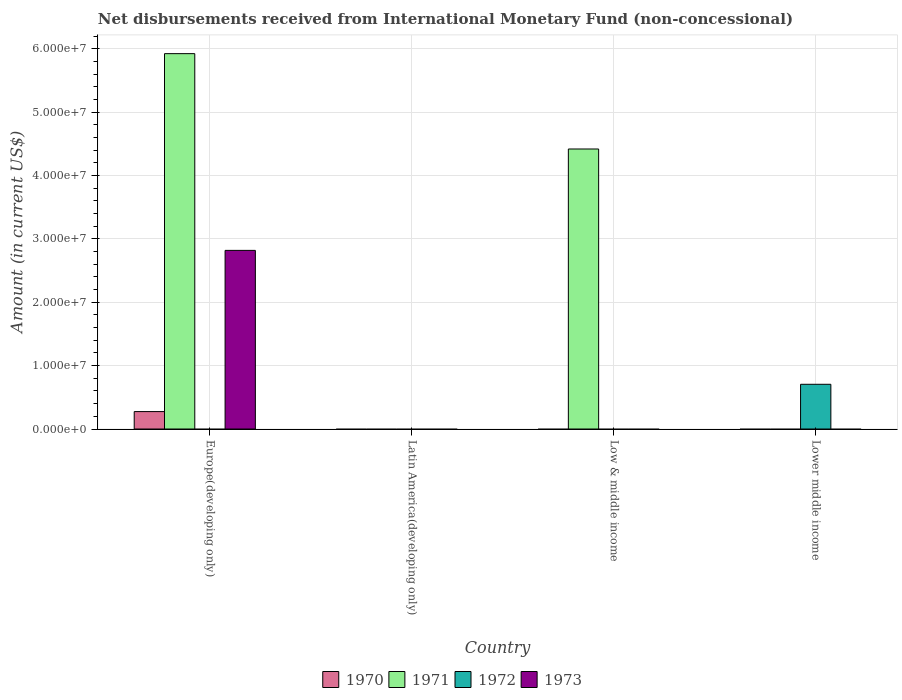How many different coloured bars are there?
Provide a succinct answer. 4. Are the number of bars on each tick of the X-axis equal?
Your answer should be compact. No. What is the label of the 1st group of bars from the left?
Give a very brief answer. Europe(developing only). In how many cases, is the number of bars for a given country not equal to the number of legend labels?
Provide a succinct answer. 4. Across all countries, what is the maximum amount of disbursements received from International Monetary Fund in 1972?
Keep it short and to the point. 7.06e+06. In which country was the amount of disbursements received from International Monetary Fund in 1973 maximum?
Make the answer very short. Europe(developing only). What is the total amount of disbursements received from International Monetary Fund in 1972 in the graph?
Make the answer very short. 7.06e+06. What is the difference between the amount of disbursements received from International Monetary Fund in 1971 in Europe(developing only) and that in Low & middle income?
Provide a succinct answer. 1.50e+07. What is the difference between the amount of disbursements received from International Monetary Fund in 1970 in Europe(developing only) and the amount of disbursements received from International Monetary Fund in 1971 in Lower middle income?
Your response must be concise. 2.75e+06. What is the average amount of disbursements received from International Monetary Fund in 1973 per country?
Provide a short and direct response. 7.05e+06. What is the difference between the amount of disbursements received from International Monetary Fund of/in 1973 and amount of disbursements received from International Monetary Fund of/in 1971 in Europe(developing only)?
Offer a terse response. -3.10e+07. What is the ratio of the amount of disbursements received from International Monetary Fund in 1971 in Europe(developing only) to that in Low & middle income?
Offer a very short reply. 1.34. What is the difference between the highest and the lowest amount of disbursements received from International Monetary Fund in 1970?
Your answer should be compact. 2.75e+06. Is it the case that in every country, the sum of the amount of disbursements received from International Monetary Fund in 1970 and amount of disbursements received from International Monetary Fund in 1973 is greater than the sum of amount of disbursements received from International Monetary Fund in 1971 and amount of disbursements received from International Monetary Fund in 1972?
Provide a short and direct response. No. Is it the case that in every country, the sum of the amount of disbursements received from International Monetary Fund in 1970 and amount of disbursements received from International Monetary Fund in 1972 is greater than the amount of disbursements received from International Monetary Fund in 1971?
Provide a succinct answer. No. Are all the bars in the graph horizontal?
Your answer should be very brief. No. How many countries are there in the graph?
Your answer should be very brief. 4. What is the difference between two consecutive major ticks on the Y-axis?
Make the answer very short. 1.00e+07. Are the values on the major ticks of Y-axis written in scientific E-notation?
Offer a terse response. Yes. Does the graph contain grids?
Your answer should be compact. Yes. What is the title of the graph?
Ensure brevity in your answer.  Net disbursements received from International Monetary Fund (non-concessional). What is the label or title of the X-axis?
Make the answer very short. Country. What is the Amount (in current US$) in 1970 in Europe(developing only)?
Offer a terse response. 2.75e+06. What is the Amount (in current US$) in 1971 in Europe(developing only)?
Your response must be concise. 5.92e+07. What is the Amount (in current US$) in 1973 in Europe(developing only)?
Your response must be concise. 2.82e+07. What is the Amount (in current US$) of 1972 in Latin America(developing only)?
Offer a terse response. 0. What is the Amount (in current US$) in 1971 in Low & middle income?
Make the answer very short. 4.42e+07. What is the Amount (in current US$) in 1972 in Low & middle income?
Your response must be concise. 0. What is the Amount (in current US$) of 1973 in Low & middle income?
Offer a very short reply. 0. What is the Amount (in current US$) in 1970 in Lower middle income?
Keep it short and to the point. 0. What is the Amount (in current US$) of 1971 in Lower middle income?
Provide a short and direct response. 0. What is the Amount (in current US$) of 1972 in Lower middle income?
Your response must be concise. 7.06e+06. What is the Amount (in current US$) of 1973 in Lower middle income?
Give a very brief answer. 0. Across all countries, what is the maximum Amount (in current US$) in 1970?
Provide a succinct answer. 2.75e+06. Across all countries, what is the maximum Amount (in current US$) in 1971?
Provide a succinct answer. 5.92e+07. Across all countries, what is the maximum Amount (in current US$) in 1972?
Provide a short and direct response. 7.06e+06. Across all countries, what is the maximum Amount (in current US$) in 1973?
Provide a succinct answer. 2.82e+07. Across all countries, what is the minimum Amount (in current US$) of 1971?
Make the answer very short. 0. Across all countries, what is the minimum Amount (in current US$) in 1973?
Keep it short and to the point. 0. What is the total Amount (in current US$) of 1970 in the graph?
Your answer should be compact. 2.75e+06. What is the total Amount (in current US$) of 1971 in the graph?
Keep it short and to the point. 1.03e+08. What is the total Amount (in current US$) in 1972 in the graph?
Provide a short and direct response. 7.06e+06. What is the total Amount (in current US$) of 1973 in the graph?
Your answer should be compact. 2.82e+07. What is the difference between the Amount (in current US$) in 1971 in Europe(developing only) and that in Low & middle income?
Offer a terse response. 1.50e+07. What is the difference between the Amount (in current US$) in 1970 in Europe(developing only) and the Amount (in current US$) in 1971 in Low & middle income?
Ensure brevity in your answer.  -4.14e+07. What is the difference between the Amount (in current US$) in 1970 in Europe(developing only) and the Amount (in current US$) in 1972 in Lower middle income?
Your answer should be compact. -4.31e+06. What is the difference between the Amount (in current US$) in 1971 in Europe(developing only) and the Amount (in current US$) in 1972 in Lower middle income?
Ensure brevity in your answer.  5.22e+07. What is the difference between the Amount (in current US$) in 1971 in Low & middle income and the Amount (in current US$) in 1972 in Lower middle income?
Provide a succinct answer. 3.71e+07. What is the average Amount (in current US$) of 1970 per country?
Give a very brief answer. 6.88e+05. What is the average Amount (in current US$) in 1971 per country?
Your answer should be compact. 2.59e+07. What is the average Amount (in current US$) in 1972 per country?
Keep it short and to the point. 1.76e+06. What is the average Amount (in current US$) in 1973 per country?
Offer a terse response. 7.05e+06. What is the difference between the Amount (in current US$) of 1970 and Amount (in current US$) of 1971 in Europe(developing only)?
Your response must be concise. -5.65e+07. What is the difference between the Amount (in current US$) in 1970 and Amount (in current US$) in 1973 in Europe(developing only)?
Your answer should be compact. -2.54e+07. What is the difference between the Amount (in current US$) in 1971 and Amount (in current US$) in 1973 in Europe(developing only)?
Provide a short and direct response. 3.10e+07. What is the ratio of the Amount (in current US$) in 1971 in Europe(developing only) to that in Low & middle income?
Offer a terse response. 1.34. What is the difference between the highest and the lowest Amount (in current US$) in 1970?
Make the answer very short. 2.75e+06. What is the difference between the highest and the lowest Amount (in current US$) in 1971?
Make the answer very short. 5.92e+07. What is the difference between the highest and the lowest Amount (in current US$) in 1972?
Provide a succinct answer. 7.06e+06. What is the difference between the highest and the lowest Amount (in current US$) in 1973?
Your answer should be very brief. 2.82e+07. 